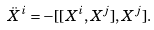<formula> <loc_0><loc_0><loc_500><loc_500>\ddot { X } ^ { i } = - [ [ X ^ { i } , X ^ { j } ] , X ^ { j } ] .</formula> 